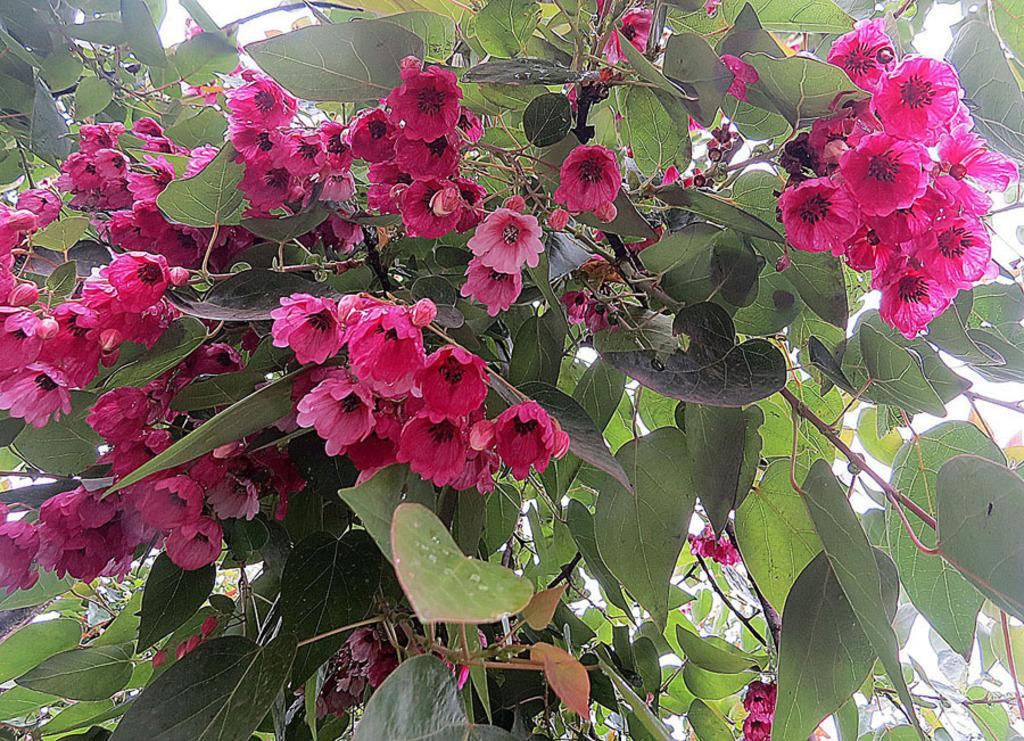What is located in the center of the image? There are trees in the center of the image. What other elements can be seen in the image? There are flowers in the image. What is the color of the flowers? The flowers are pink in color. What type of oatmeal is being used to paint the flowers in the image? There is no oatmeal or painting activity present in the image; it features trees and pink flowers. Can you tell me the position of the brush in the image? There is no brush present in the image. 